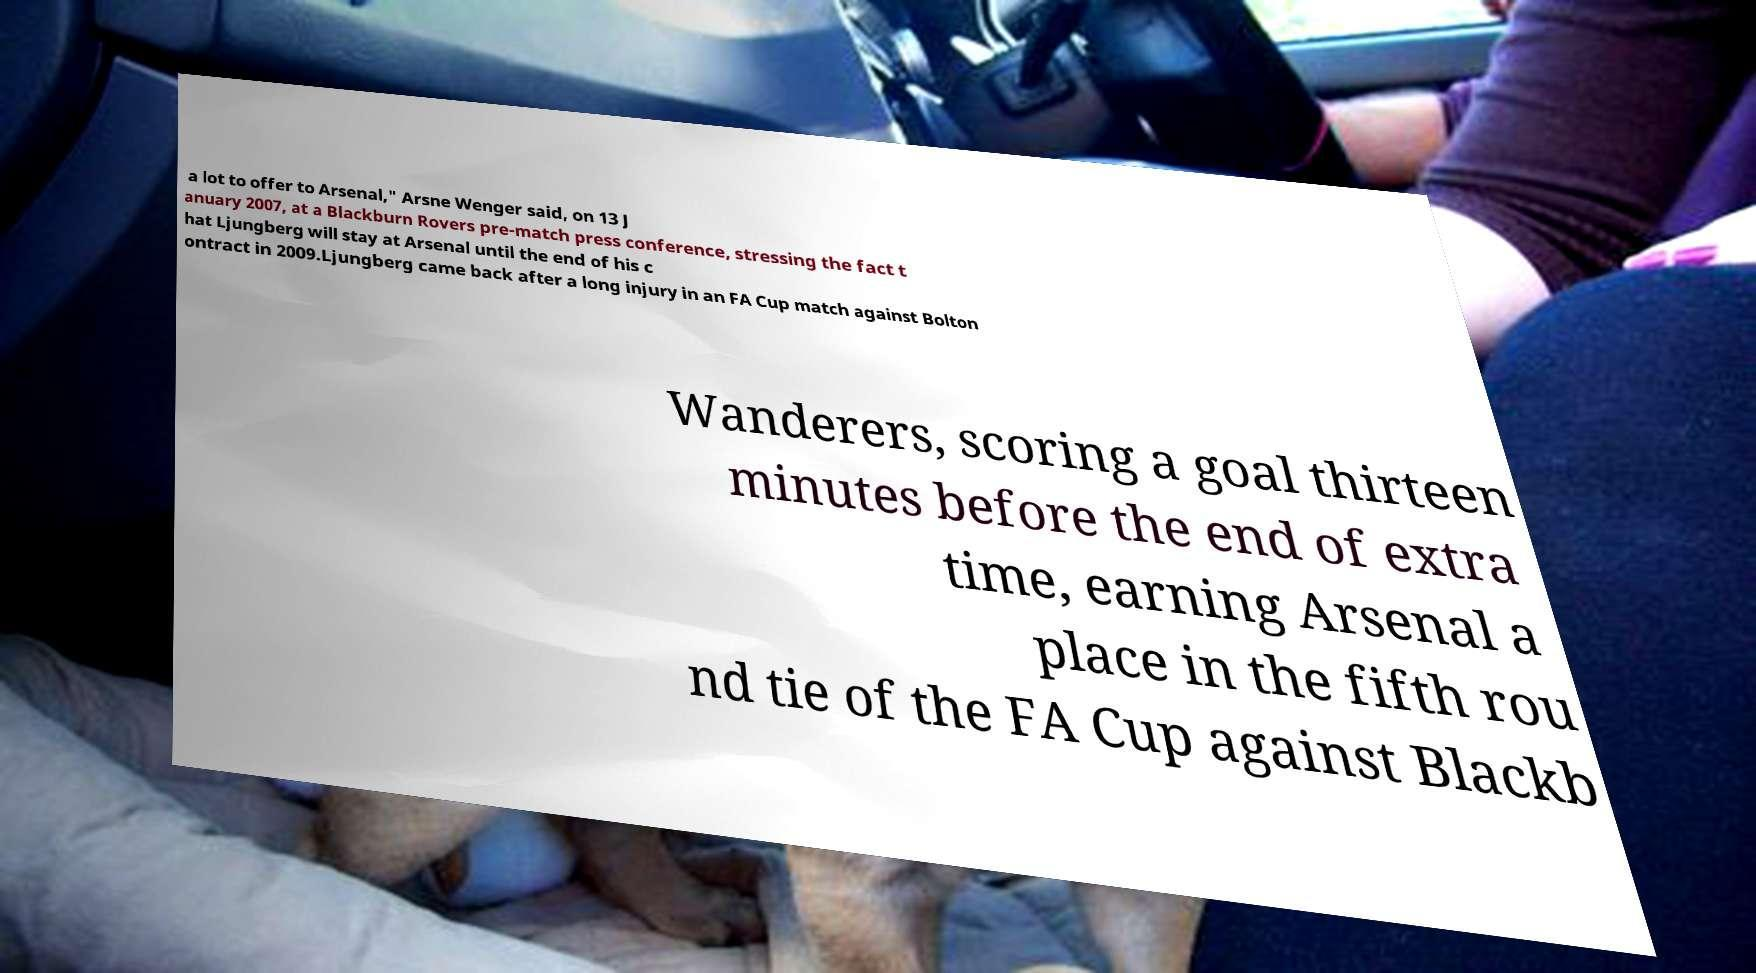For documentation purposes, I need the text within this image transcribed. Could you provide that? a lot to offer to Arsenal," Arsne Wenger said, on 13 J anuary 2007, at a Blackburn Rovers pre-match press conference, stressing the fact t hat Ljungberg will stay at Arsenal until the end of his c ontract in 2009.Ljungberg came back after a long injury in an FA Cup match against Bolton Wanderers, scoring a goal thirteen minutes before the end of extra time, earning Arsenal a place in the fifth rou nd tie of the FA Cup against Blackb 